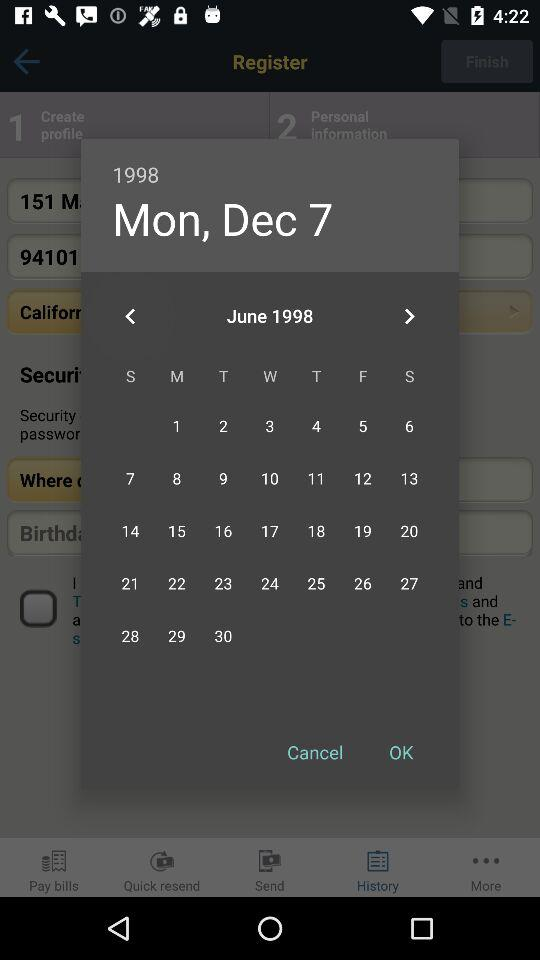What is the date? The date is Monday, June 7, December, 1998. 